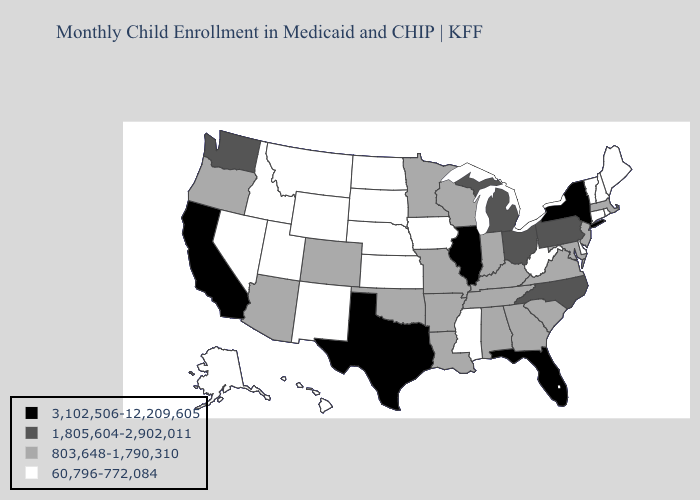Among the states that border South Dakota , which have the lowest value?
Concise answer only. Iowa, Montana, Nebraska, North Dakota, Wyoming. What is the lowest value in states that border Kentucky?
Answer briefly. 60,796-772,084. Name the states that have a value in the range 3,102,506-12,209,605?
Give a very brief answer. California, Florida, Illinois, New York, Texas. Which states have the lowest value in the Northeast?
Give a very brief answer. Connecticut, Maine, New Hampshire, Rhode Island, Vermont. Among the states that border Pennsylvania , does West Virginia have the lowest value?
Short answer required. Yes. Among the states that border Oklahoma , does New Mexico have the lowest value?
Answer briefly. Yes. Name the states that have a value in the range 60,796-772,084?
Concise answer only. Alaska, Connecticut, Delaware, Hawaii, Idaho, Iowa, Kansas, Maine, Mississippi, Montana, Nebraska, Nevada, New Hampshire, New Mexico, North Dakota, Rhode Island, South Dakota, Utah, Vermont, West Virginia, Wyoming. What is the highest value in the USA?
Give a very brief answer. 3,102,506-12,209,605. Name the states that have a value in the range 60,796-772,084?
Keep it brief. Alaska, Connecticut, Delaware, Hawaii, Idaho, Iowa, Kansas, Maine, Mississippi, Montana, Nebraska, Nevada, New Hampshire, New Mexico, North Dakota, Rhode Island, South Dakota, Utah, Vermont, West Virginia, Wyoming. What is the highest value in states that border Massachusetts?
Be succinct. 3,102,506-12,209,605. Which states have the highest value in the USA?
Short answer required. California, Florida, Illinois, New York, Texas. Name the states that have a value in the range 1,805,604-2,902,011?
Short answer required. Michigan, North Carolina, Ohio, Pennsylvania, Washington. Does Texas have the highest value in the USA?
Give a very brief answer. Yes. What is the value of Delaware?
Keep it brief. 60,796-772,084. Does Oregon have the lowest value in the West?
Quick response, please. No. 